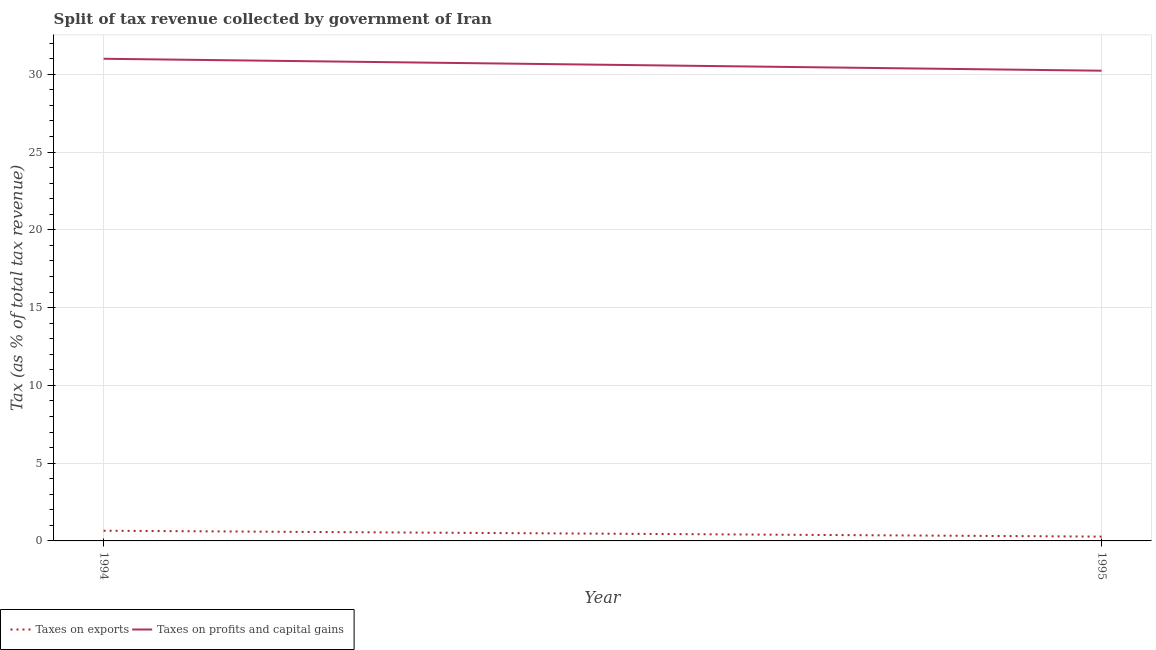Does the line corresponding to percentage of revenue obtained from taxes on profits and capital gains intersect with the line corresponding to percentage of revenue obtained from taxes on exports?
Provide a succinct answer. No. Is the number of lines equal to the number of legend labels?
Make the answer very short. Yes. What is the percentage of revenue obtained from taxes on exports in 1994?
Give a very brief answer. 0.65. Across all years, what is the maximum percentage of revenue obtained from taxes on profits and capital gains?
Your answer should be very brief. 31. Across all years, what is the minimum percentage of revenue obtained from taxes on exports?
Provide a succinct answer. 0.28. What is the total percentage of revenue obtained from taxes on exports in the graph?
Provide a short and direct response. 0.93. What is the difference between the percentage of revenue obtained from taxes on exports in 1994 and that in 1995?
Your answer should be very brief. 0.38. What is the difference between the percentage of revenue obtained from taxes on profits and capital gains in 1994 and the percentage of revenue obtained from taxes on exports in 1995?
Give a very brief answer. 30.72. What is the average percentage of revenue obtained from taxes on profits and capital gains per year?
Provide a succinct answer. 30.62. In the year 1995, what is the difference between the percentage of revenue obtained from taxes on exports and percentage of revenue obtained from taxes on profits and capital gains?
Your response must be concise. -29.96. What is the ratio of the percentage of revenue obtained from taxes on profits and capital gains in 1994 to that in 1995?
Provide a short and direct response. 1.03. Is the percentage of revenue obtained from taxes on profits and capital gains in 1994 less than that in 1995?
Your answer should be compact. No. In how many years, is the percentage of revenue obtained from taxes on exports greater than the average percentage of revenue obtained from taxes on exports taken over all years?
Your answer should be very brief. 1. Does the percentage of revenue obtained from taxes on exports monotonically increase over the years?
Offer a very short reply. No. Is the percentage of revenue obtained from taxes on exports strictly less than the percentage of revenue obtained from taxes on profits and capital gains over the years?
Your response must be concise. Yes. How many years are there in the graph?
Give a very brief answer. 2. Does the graph contain grids?
Ensure brevity in your answer.  Yes. Where does the legend appear in the graph?
Your answer should be very brief. Bottom left. How many legend labels are there?
Provide a succinct answer. 2. How are the legend labels stacked?
Make the answer very short. Horizontal. What is the title of the graph?
Provide a succinct answer. Split of tax revenue collected by government of Iran. Does "Resident" appear as one of the legend labels in the graph?
Your answer should be very brief. No. What is the label or title of the Y-axis?
Your answer should be very brief. Tax (as % of total tax revenue). What is the Tax (as % of total tax revenue) in Taxes on exports in 1994?
Offer a terse response. 0.65. What is the Tax (as % of total tax revenue) of Taxes on profits and capital gains in 1994?
Your response must be concise. 31. What is the Tax (as % of total tax revenue) of Taxes on exports in 1995?
Provide a succinct answer. 0.28. What is the Tax (as % of total tax revenue) of Taxes on profits and capital gains in 1995?
Provide a succinct answer. 30.23. Across all years, what is the maximum Tax (as % of total tax revenue) in Taxes on exports?
Offer a very short reply. 0.65. Across all years, what is the maximum Tax (as % of total tax revenue) in Taxes on profits and capital gains?
Make the answer very short. 31. Across all years, what is the minimum Tax (as % of total tax revenue) of Taxes on exports?
Offer a very short reply. 0.28. Across all years, what is the minimum Tax (as % of total tax revenue) in Taxes on profits and capital gains?
Provide a short and direct response. 30.23. What is the total Tax (as % of total tax revenue) of Taxes on exports in the graph?
Keep it short and to the point. 0.93. What is the total Tax (as % of total tax revenue) in Taxes on profits and capital gains in the graph?
Ensure brevity in your answer.  61.23. What is the difference between the Tax (as % of total tax revenue) in Taxes on exports in 1994 and that in 1995?
Provide a short and direct response. 0.38. What is the difference between the Tax (as % of total tax revenue) of Taxes on profits and capital gains in 1994 and that in 1995?
Ensure brevity in your answer.  0.77. What is the difference between the Tax (as % of total tax revenue) in Taxes on exports in 1994 and the Tax (as % of total tax revenue) in Taxes on profits and capital gains in 1995?
Give a very brief answer. -29.58. What is the average Tax (as % of total tax revenue) in Taxes on exports per year?
Make the answer very short. 0.47. What is the average Tax (as % of total tax revenue) of Taxes on profits and capital gains per year?
Ensure brevity in your answer.  30.62. In the year 1994, what is the difference between the Tax (as % of total tax revenue) of Taxes on exports and Tax (as % of total tax revenue) of Taxes on profits and capital gains?
Your answer should be compact. -30.35. In the year 1995, what is the difference between the Tax (as % of total tax revenue) in Taxes on exports and Tax (as % of total tax revenue) in Taxes on profits and capital gains?
Provide a short and direct response. -29.96. What is the ratio of the Tax (as % of total tax revenue) in Taxes on exports in 1994 to that in 1995?
Offer a terse response. 2.36. What is the ratio of the Tax (as % of total tax revenue) of Taxes on profits and capital gains in 1994 to that in 1995?
Your answer should be very brief. 1.03. What is the difference between the highest and the second highest Tax (as % of total tax revenue) of Taxes on exports?
Give a very brief answer. 0.38. What is the difference between the highest and the second highest Tax (as % of total tax revenue) of Taxes on profits and capital gains?
Provide a short and direct response. 0.77. What is the difference between the highest and the lowest Tax (as % of total tax revenue) of Taxes on exports?
Your answer should be compact. 0.38. What is the difference between the highest and the lowest Tax (as % of total tax revenue) of Taxes on profits and capital gains?
Offer a very short reply. 0.77. 